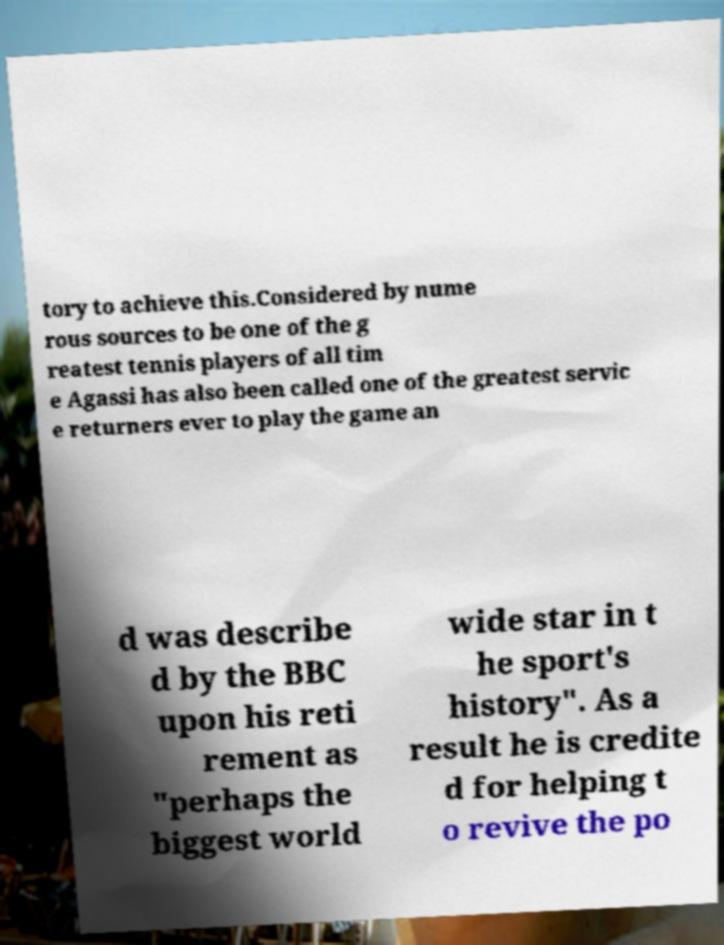Can you read and provide the text displayed in the image?This photo seems to have some interesting text. Can you extract and type it out for me? tory to achieve this.Considered by nume rous sources to be one of the g reatest tennis players of all tim e Agassi has also been called one of the greatest servic e returners ever to play the game an d was describe d by the BBC upon his reti rement as "perhaps the biggest world wide star in t he sport's history". As a result he is credite d for helping t o revive the po 